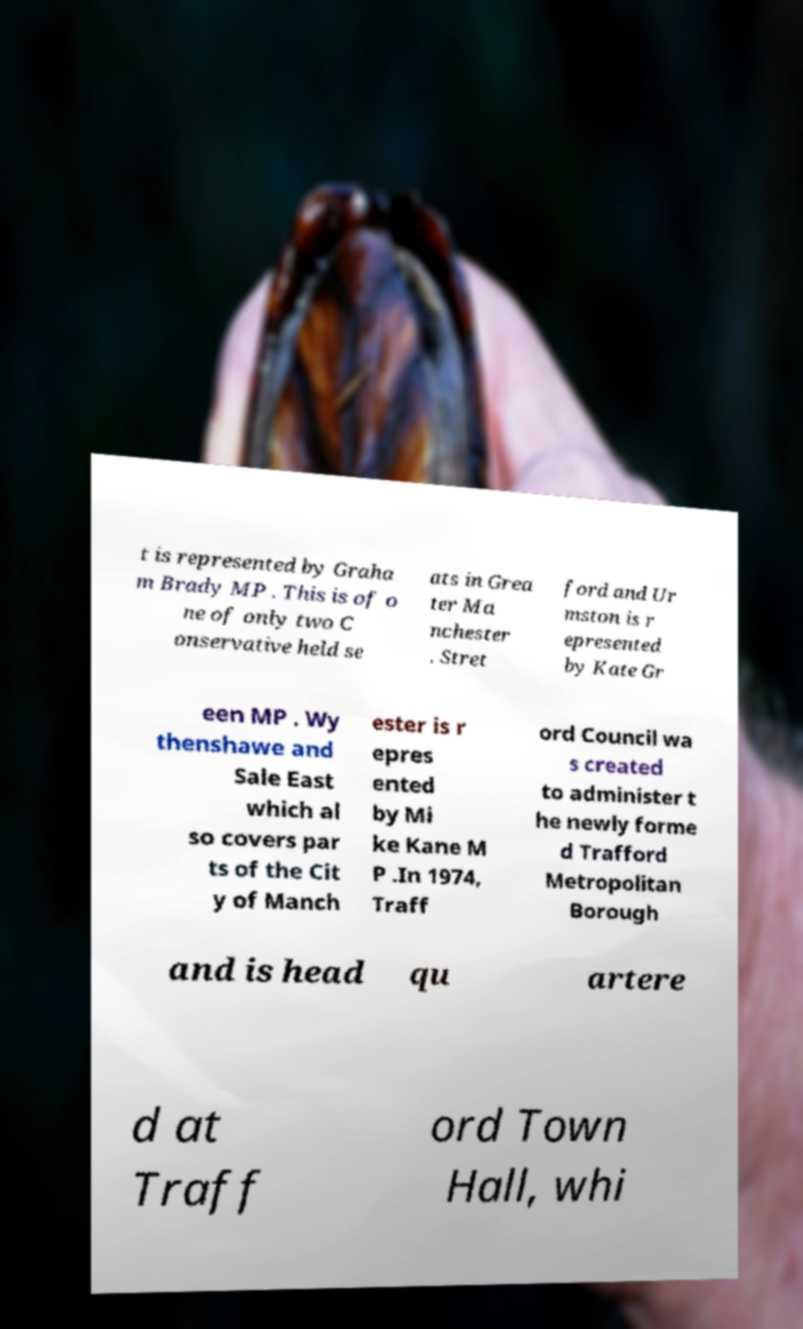Please identify and transcribe the text found in this image. t is represented by Graha m Brady MP . This is of o ne of only two C onservative held se ats in Grea ter Ma nchester . Stret ford and Ur mston is r epresented by Kate Gr een MP . Wy thenshawe and Sale East which al so covers par ts of the Cit y of Manch ester is r epres ented by Mi ke Kane M P .In 1974, Traff ord Council wa s created to administer t he newly forme d Trafford Metropolitan Borough and is head qu artere d at Traff ord Town Hall, whi 